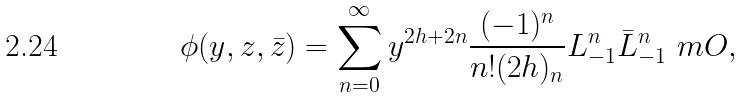<formula> <loc_0><loc_0><loc_500><loc_500>\phi ( y , z , \bar { z } ) = \sum _ { n = 0 } ^ { \infty } y ^ { 2 h + 2 n } \frac { ( - 1 ) ^ { n } } { n ! ( 2 h ) _ { n } } L _ { - 1 } ^ { n } \bar { L } _ { - 1 } ^ { n } \ m O ,</formula> 